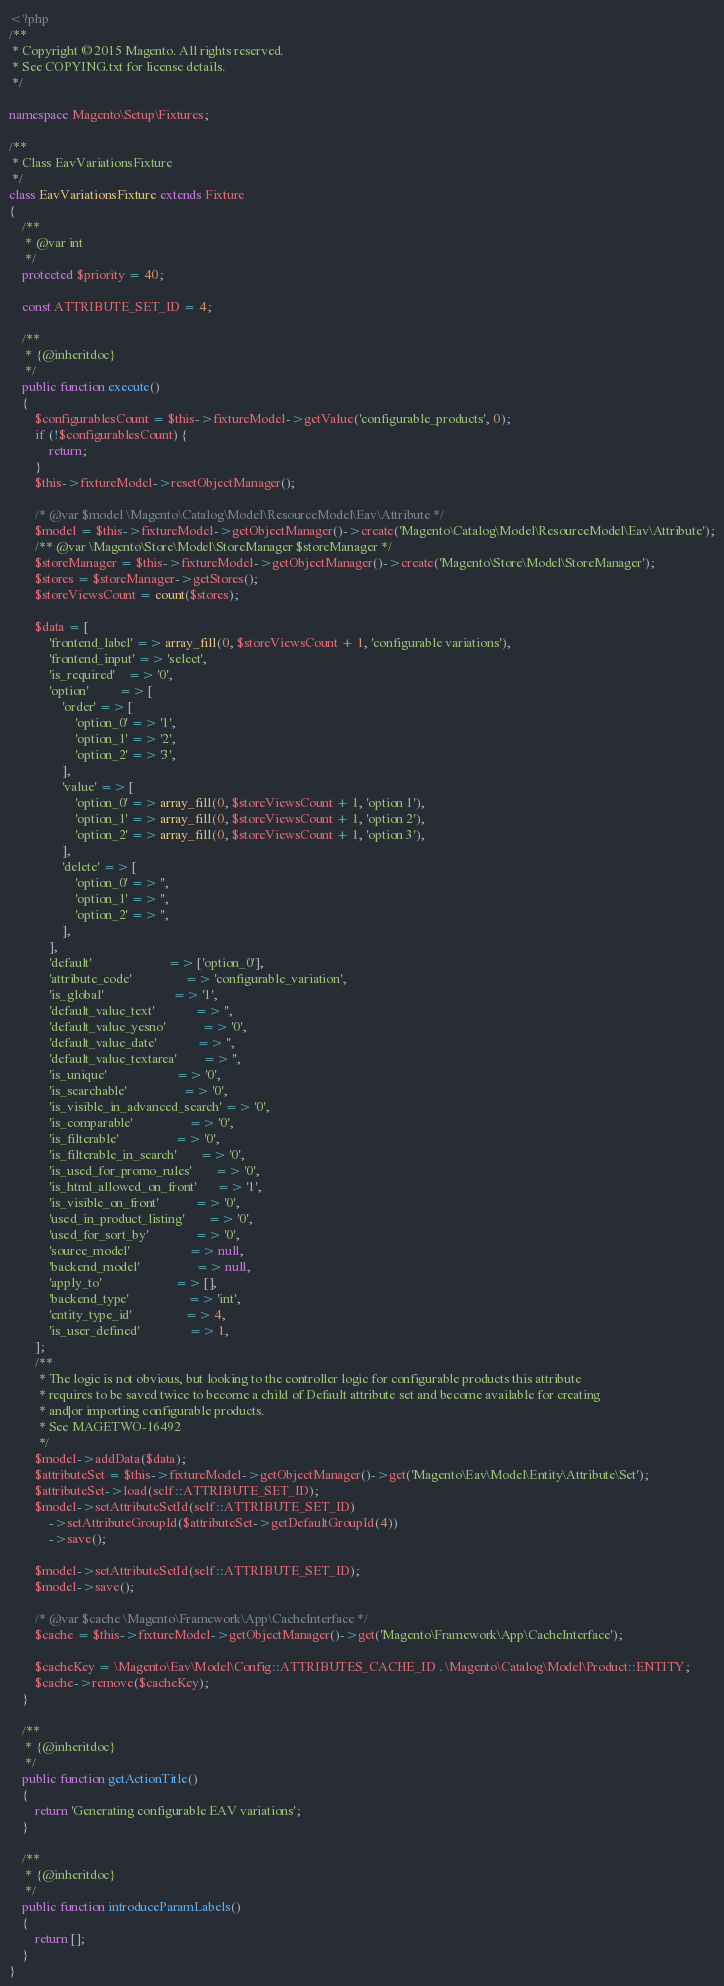Convert code to text. <code><loc_0><loc_0><loc_500><loc_500><_PHP_><?php
/**
 * Copyright © 2015 Magento. All rights reserved.
 * See COPYING.txt for license details.
 */

namespace Magento\Setup\Fixtures;

/**
 * Class EavVariationsFixture
 */
class EavVariationsFixture extends Fixture
{
    /**
     * @var int
     */
    protected $priority = 40;

    const ATTRIBUTE_SET_ID = 4;

    /**
     * {@inheritdoc}
     */
    public function execute()
    {
        $configurablesCount = $this->fixtureModel->getValue('configurable_products', 0);
        if (!$configurablesCount) {
            return;
        }
        $this->fixtureModel->resetObjectManager();

        /* @var $model \Magento\Catalog\Model\ResourceModel\Eav\Attribute */
        $model = $this->fixtureModel->getObjectManager()->create('Magento\Catalog\Model\ResourceModel\Eav\Attribute');
        /** @var \Magento\Store\Model\StoreManager $storeManager */
        $storeManager = $this->fixtureModel->getObjectManager()->create('Magento\Store\Model\StoreManager');
        $stores = $storeManager->getStores();
        $storeViewsCount = count($stores);

        $data = [
            'frontend_label' => array_fill(0, $storeViewsCount + 1, 'configurable variations'),
            'frontend_input' => 'select',
            'is_required'    => '0',
            'option'         => [
                'order' => [
                    'option_0' => '1',
                    'option_1' => '2',
                    'option_2' => '3',
                ],
                'value' => [
                    'option_0' => array_fill(0, $storeViewsCount + 1, 'option 1'),
                    'option_1' => array_fill(0, $storeViewsCount + 1, 'option 2'),
                    'option_2' => array_fill(0, $storeViewsCount + 1, 'option 3'),
                ],
                'delete' => [
                    'option_0' => '',
                    'option_1' => '',
                    'option_2' => '',
                ],
            ],
            'default'                       => ['option_0'],
            'attribute_code'                => 'configurable_variation',
            'is_global'                     => '1',
            'default_value_text'            => '',
            'default_value_yesno'           => '0',
            'default_value_date'            => '',
            'default_value_textarea'        => '',
            'is_unique'                     => '0',
            'is_searchable'                 => '0',
            'is_visible_in_advanced_search' => '0',
            'is_comparable'                 => '0',
            'is_filterable'                 => '0',
            'is_filterable_in_search'       => '0',
            'is_used_for_promo_rules'       => '0',
            'is_html_allowed_on_front'      => '1',
            'is_visible_on_front'           => '0',
            'used_in_product_listing'       => '0',
            'used_for_sort_by'              => '0',
            'source_model'                  => null,
            'backend_model'                 => null,
            'apply_to'                      => [],
            'backend_type'                  => 'int',
            'entity_type_id'                => 4,
            'is_user_defined'               => 1,
        ];
        /**
         * The logic is not obvious, but looking to the controller logic for configurable products this attribute
         * requires to be saved twice to become a child of Default attribute set and become available for creating
         * and|or importing configurable products.
         * See MAGETWO-16492
         */
        $model->addData($data);
        $attributeSet = $this->fixtureModel->getObjectManager()->get('Magento\Eav\Model\Entity\Attribute\Set');
        $attributeSet->load(self::ATTRIBUTE_SET_ID);
        $model->setAttributeSetId(self::ATTRIBUTE_SET_ID)
            ->setAttributeGroupId($attributeSet->getDefaultGroupId(4))
            ->save();

        $model->setAttributeSetId(self::ATTRIBUTE_SET_ID);
        $model->save();

        /* @var $cache \Magento\Framework\App\CacheInterface */
        $cache = $this->fixtureModel->getObjectManager()->get('Magento\Framework\App\CacheInterface');

        $cacheKey = \Magento\Eav\Model\Config::ATTRIBUTES_CACHE_ID . \Magento\Catalog\Model\Product::ENTITY;
        $cache->remove($cacheKey);
    }

    /**
     * {@inheritdoc}
     */
    public function getActionTitle()
    {
        return 'Generating configurable EAV variations';
    }

    /**
     * {@inheritdoc}
     */
    public function introduceParamLabels()
    {
        return [];
    }
}
</code> 